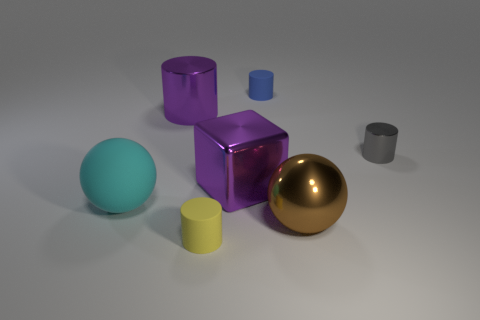Add 2 brown metallic balls. How many objects exist? 9 Subtract all green cylinders. Subtract all brown cubes. How many cylinders are left? 4 Subtract all spheres. How many objects are left? 5 Subtract all small gray metallic cylinders. Subtract all blue cylinders. How many objects are left? 5 Add 7 big purple objects. How many big purple objects are left? 9 Add 1 purple cylinders. How many purple cylinders exist? 2 Subtract 0 yellow spheres. How many objects are left? 7 